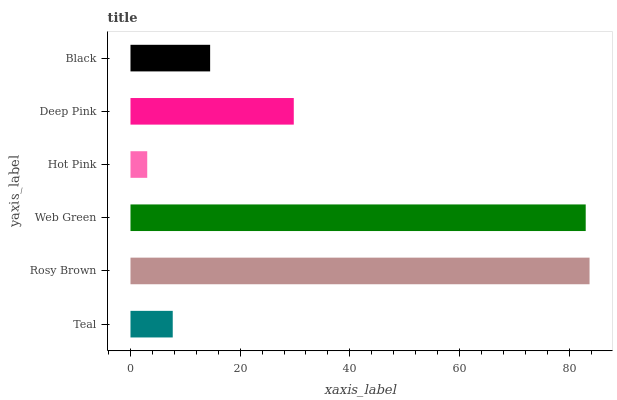Is Hot Pink the minimum?
Answer yes or no. Yes. Is Rosy Brown the maximum?
Answer yes or no. Yes. Is Web Green the minimum?
Answer yes or no. No. Is Web Green the maximum?
Answer yes or no. No. Is Rosy Brown greater than Web Green?
Answer yes or no. Yes. Is Web Green less than Rosy Brown?
Answer yes or no. Yes. Is Web Green greater than Rosy Brown?
Answer yes or no. No. Is Rosy Brown less than Web Green?
Answer yes or no. No. Is Deep Pink the high median?
Answer yes or no. Yes. Is Black the low median?
Answer yes or no. Yes. Is Web Green the high median?
Answer yes or no. No. Is Web Green the low median?
Answer yes or no. No. 